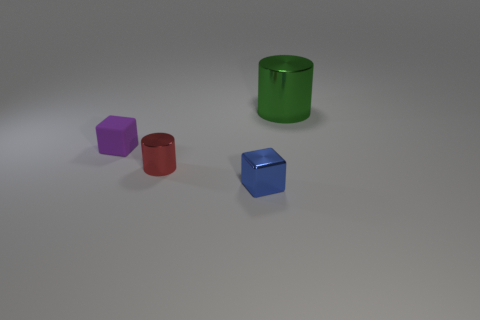Add 1 green objects. How many objects exist? 5 Add 2 large green cylinders. How many large green cylinders exist? 3 Subtract 0 purple cylinders. How many objects are left? 4 Subtract all red rubber cylinders. Subtract all small shiny things. How many objects are left? 2 Add 1 big metal cylinders. How many big metal cylinders are left? 2 